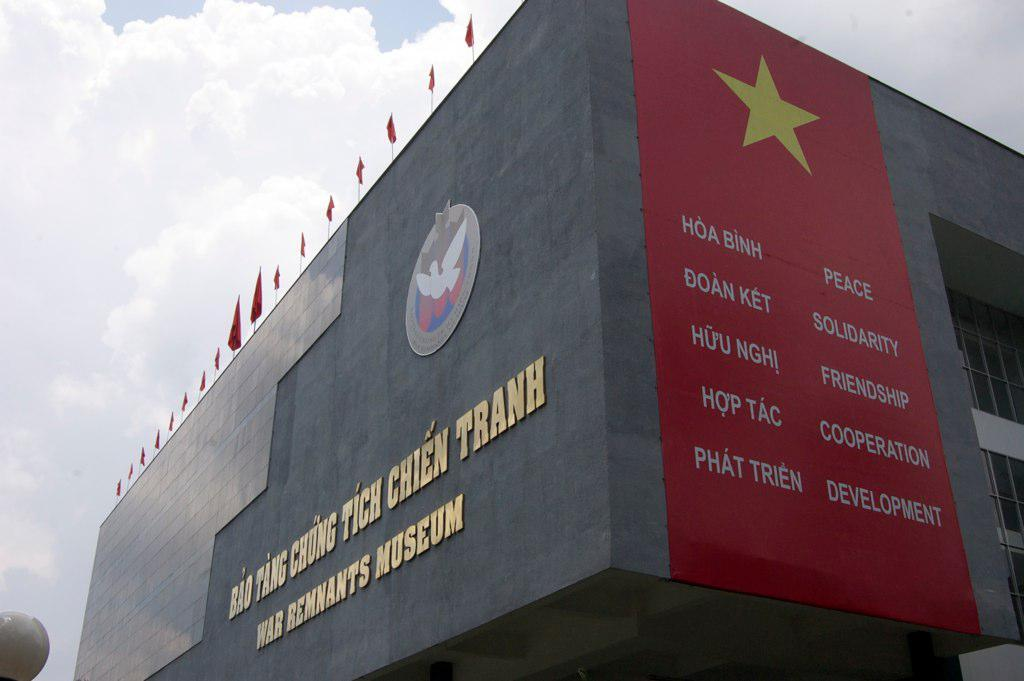What type of structure is present in the image? There is a building in the image. Does the building have any distinguishing features? Yes, the building has a logo, a poster, flags, and text on it. What can be seen in the background of the image? The sky is visible in the background of the image. What is the condition of the sky in the image? The sky has clouds in it. How much pollution is visible in the image? There is no information about pollution in the image, as it focuses on the building and its features. 